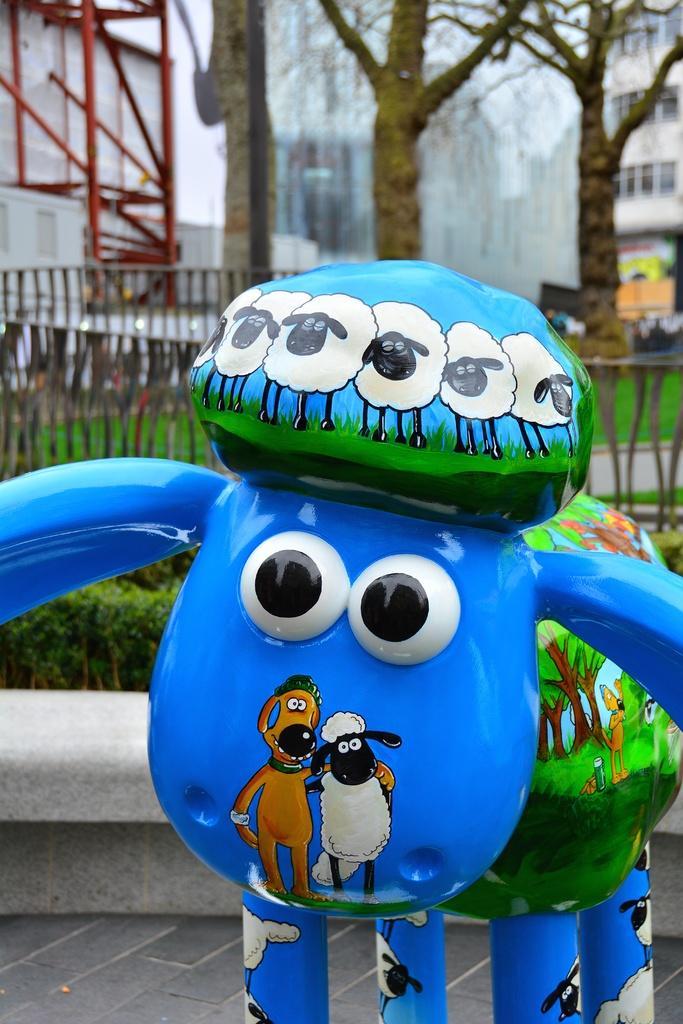How would you summarize this image in a sentence or two? In the foreground of this image, there is a toy statue. Behind it, there are plants, railing, trees and few buildings. 